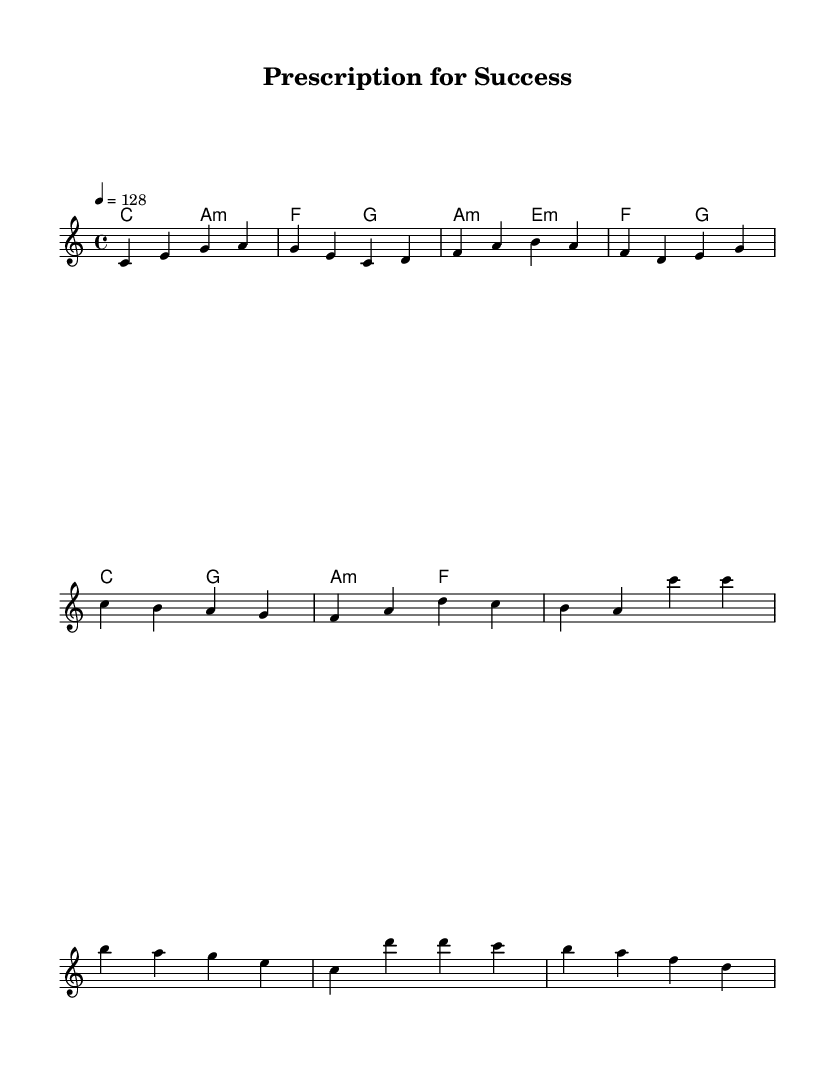What is the key signature of this music? The key signature is indicated in the global section at the beginning. It states "c \major," meaning there are no sharps or flats.
Answer: C major What is the time signature of this music? The time signature is indicated in the global section as "4/4," which shows that there are four beats in each measure and the quarter note gets one beat.
Answer: 4/4 What is the tempo marking? The tempo marking is found in the global section where it says "4 = 128," which indicates the metronome marking for the piece being performed at 128 beats per minute.
Answer: 128 How many measures are in the verse section? By counting the melody notes for the verse, there are a total of 8 beats (or 2 measures), as 4 quarter notes constitute 1 measure, and there are 2 groups of 4 quarter notes.
Answer: 2 What is the lyrical theme of the chorus? The chorus lyrics reveal a theme of confidence and independence in business success, stating "I've got the prescription for success, no need to spy, I'll pass the test." This conveys a sense of self-assurance and rivalry.
Answer: Confidence What chord is played during the chorus? The chords listed in the score reveal that during the chorus, the chords "c" and "g" are played. This is interpreted by looking at the harmonies section, where the corresponding chords are shown under the melody.
Answer: c and g What is the overall message conveyed in the lyrics of this song? The lyrics express a strong entrepreneurial spirit, highlighting determination and ambition in achieving success without resorting to unethical means like spying. This is inferred from the lyrics in the pre-chorus and chorus sections.
Answer: Entrepreneurial spirit 